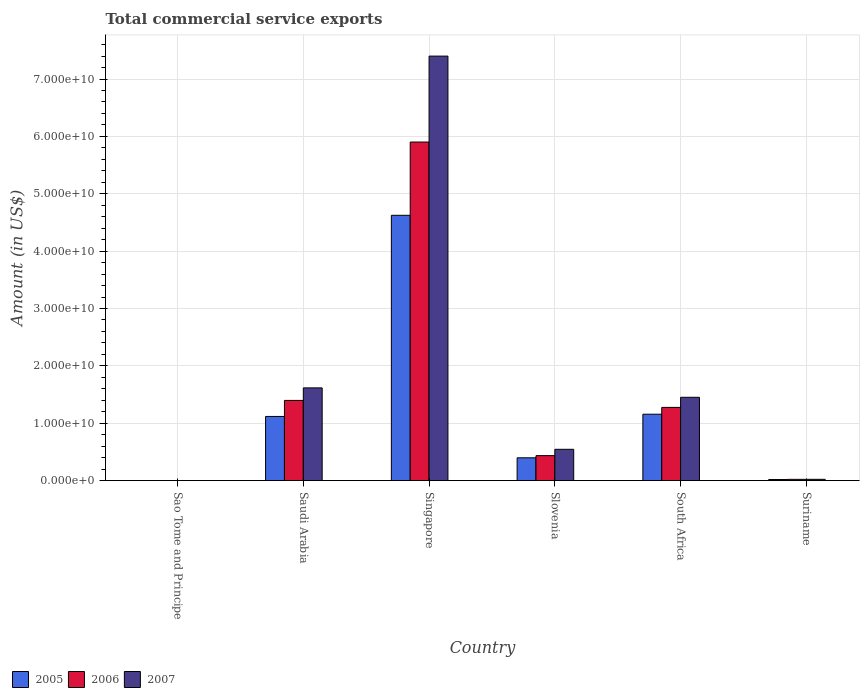How many different coloured bars are there?
Offer a terse response. 3. How many groups of bars are there?
Your answer should be very brief. 6. Are the number of bars on each tick of the X-axis equal?
Provide a succinct answer. Yes. What is the label of the 3rd group of bars from the left?
Provide a succinct answer. Singapore. In how many cases, is the number of bars for a given country not equal to the number of legend labels?
Provide a succinct answer. 0. What is the total commercial service exports in 2007 in Saudi Arabia?
Your response must be concise. 1.62e+1. Across all countries, what is the maximum total commercial service exports in 2005?
Provide a succinct answer. 4.62e+1. Across all countries, what is the minimum total commercial service exports in 2005?
Offer a terse response. 8.86e+06. In which country was the total commercial service exports in 2006 maximum?
Your answer should be very brief. Singapore. In which country was the total commercial service exports in 2007 minimum?
Keep it short and to the point. Sao Tome and Principe. What is the total total commercial service exports in 2006 in the graph?
Keep it short and to the point. 9.03e+1. What is the difference between the total commercial service exports in 2007 in Singapore and that in South Africa?
Your answer should be very brief. 5.95e+1. What is the difference between the total commercial service exports in 2007 in South Africa and the total commercial service exports in 2006 in Singapore?
Your response must be concise. -4.45e+1. What is the average total commercial service exports in 2007 per country?
Your answer should be very brief. 1.84e+1. What is the difference between the total commercial service exports of/in 2006 and total commercial service exports of/in 2007 in Suriname?
Keep it short and to the point. -5.10e+06. In how many countries, is the total commercial service exports in 2005 greater than 54000000000 US$?
Your answer should be very brief. 0. What is the ratio of the total commercial service exports in 2005 in Saudi Arabia to that in South Africa?
Ensure brevity in your answer.  0.97. What is the difference between the highest and the second highest total commercial service exports in 2006?
Your response must be concise. -4.63e+1. What is the difference between the highest and the lowest total commercial service exports in 2005?
Offer a very short reply. 4.62e+1. What is the difference between two consecutive major ticks on the Y-axis?
Ensure brevity in your answer.  1.00e+1. Where does the legend appear in the graph?
Offer a terse response. Bottom left. How are the legend labels stacked?
Your answer should be compact. Horizontal. What is the title of the graph?
Provide a short and direct response. Total commercial service exports. Does "2008" appear as one of the legend labels in the graph?
Provide a short and direct response. No. What is the label or title of the X-axis?
Your answer should be very brief. Country. What is the label or title of the Y-axis?
Provide a short and direct response. Amount (in US$). What is the Amount (in US$) in 2005 in Sao Tome and Principe?
Keep it short and to the point. 8.86e+06. What is the Amount (in US$) of 2006 in Sao Tome and Principe?
Provide a short and direct response. 8.14e+06. What is the Amount (in US$) of 2007 in Sao Tome and Principe?
Provide a short and direct response. 6.43e+06. What is the Amount (in US$) of 2005 in Saudi Arabia?
Give a very brief answer. 1.12e+1. What is the Amount (in US$) of 2006 in Saudi Arabia?
Offer a very short reply. 1.40e+1. What is the Amount (in US$) of 2007 in Saudi Arabia?
Provide a short and direct response. 1.62e+1. What is the Amount (in US$) of 2005 in Singapore?
Your answer should be very brief. 4.62e+1. What is the Amount (in US$) in 2006 in Singapore?
Give a very brief answer. 5.90e+1. What is the Amount (in US$) of 2007 in Singapore?
Make the answer very short. 7.40e+1. What is the Amount (in US$) of 2005 in Slovenia?
Provide a short and direct response. 3.97e+09. What is the Amount (in US$) in 2006 in Slovenia?
Provide a succinct answer. 4.35e+09. What is the Amount (in US$) of 2007 in Slovenia?
Ensure brevity in your answer.  5.45e+09. What is the Amount (in US$) of 2005 in South Africa?
Provide a succinct answer. 1.16e+1. What is the Amount (in US$) of 2006 in South Africa?
Offer a terse response. 1.28e+1. What is the Amount (in US$) in 2007 in South Africa?
Provide a short and direct response. 1.45e+1. What is the Amount (in US$) of 2005 in Suriname?
Your answer should be very brief. 1.83e+08. What is the Amount (in US$) in 2006 in Suriname?
Offer a very short reply. 2.14e+08. What is the Amount (in US$) of 2007 in Suriname?
Provide a short and direct response. 2.19e+08. Across all countries, what is the maximum Amount (in US$) in 2005?
Your answer should be very brief. 4.62e+1. Across all countries, what is the maximum Amount (in US$) of 2006?
Provide a succinct answer. 5.90e+1. Across all countries, what is the maximum Amount (in US$) in 2007?
Ensure brevity in your answer.  7.40e+1. Across all countries, what is the minimum Amount (in US$) in 2005?
Ensure brevity in your answer.  8.86e+06. Across all countries, what is the minimum Amount (in US$) in 2006?
Your answer should be compact. 8.14e+06. Across all countries, what is the minimum Amount (in US$) in 2007?
Offer a terse response. 6.43e+06. What is the total Amount (in US$) of 2005 in the graph?
Your response must be concise. 7.32e+1. What is the total Amount (in US$) in 2006 in the graph?
Your response must be concise. 9.03e+1. What is the total Amount (in US$) in 2007 in the graph?
Your answer should be compact. 1.10e+11. What is the difference between the Amount (in US$) of 2005 in Sao Tome and Principe and that in Saudi Arabia?
Ensure brevity in your answer.  -1.12e+1. What is the difference between the Amount (in US$) of 2006 in Sao Tome and Principe and that in Saudi Arabia?
Your answer should be compact. -1.40e+1. What is the difference between the Amount (in US$) in 2007 in Sao Tome and Principe and that in Saudi Arabia?
Make the answer very short. -1.62e+1. What is the difference between the Amount (in US$) in 2005 in Sao Tome and Principe and that in Singapore?
Offer a very short reply. -4.62e+1. What is the difference between the Amount (in US$) in 2006 in Sao Tome and Principe and that in Singapore?
Make the answer very short. -5.90e+1. What is the difference between the Amount (in US$) in 2007 in Sao Tome and Principe and that in Singapore?
Offer a very short reply. -7.40e+1. What is the difference between the Amount (in US$) of 2005 in Sao Tome and Principe and that in Slovenia?
Offer a terse response. -3.96e+09. What is the difference between the Amount (in US$) of 2006 in Sao Tome and Principe and that in Slovenia?
Provide a short and direct response. -4.34e+09. What is the difference between the Amount (in US$) in 2007 in Sao Tome and Principe and that in Slovenia?
Offer a terse response. -5.44e+09. What is the difference between the Amount (in US$) of 2005 in Sao Tome and Principe and that in South Africa?
Your response must be concise. -1.16e+1. What is the difference between the Amount (in US$) in 2006 in Sao Tome and Principe and that in South Africa?
Make the answer very short. -1.27e+1. What is the difference between the Amount (in US$) of 2007 in Sao Tome and Principe and that in South Africa?
Your response must be concise. -1.45e+1. What is the difference between the Amount (in US$) in 2005 in Sao Tome and Principe and that in Suriname?
Provide a succinct answer. -1.74e+08. What is the difference between the Amount (in US$) of 2006 in Sao Tome and Principe and that in Suriname?
Offer a very short reply. -2.05e+08. What is the difference between the Amount (in US$) of 2007 in Sao Tome and Principe and that in Suriname?
Provide a short and direct response. -2.12e+08. What is the difference between the Amount (in US$) of 2005 in Saudi Arabia and that in Singapore?
Keep it short and to the point. -3.51e+1. What is the difference between the Amount (in US$) in 2006 in Saudi Arabia and that in Singapore?
Keep it short and to the point. -4.50e+1. What is the difference between the Amount (in US$) of 2007 in Saudi Arabia and that in Singapore?
Ensure brevity in your answer.  -5.78e+1. What is the difference between the Amount (in US$) in 2005 in Saudi Arabia and that in Slovenia?
Make the answer very short. 7.21e+09. What is the difference between the Amount (in US$) of 2006 in Saudi Arabia and that in Slovenia?
Your answer should be compact. 9.62e+09. What is the difference between the Amount (in US$) in 2007 in Saudi Arabia and that in Slovenia?
Offer a very short reply. 1.07e+1. What is the difference between the Amount (in US$) in 2005 in Saudi Arabia and that in South Africa?
Give a very brief answer. -3.91e+08. What is the difference between the Amount (in US$) of 2006 in Saudi Arabia and that in South Africa?
Make the answer very short. 1.22e+09. What is the difference between the Amount (in US$) in 2007 in Saudi Arabia and that in South Africa?
Provide a succinct answer. 1.64e+09. What is the difference between the Amount (in US$) in 2005 in Saudi Arabia and that in Suriname?
Provide a short and direct response. 1.10e+1. What is the difference between the Amount (in US$) in 2006 in Saudi Arabia and that in Suriname?
Provide a succinct answer. 1.38e+1. What is the difference between the Amount (in US$) in 2007 in Saudi Arabia and that in Suriname?
Keep it short and to the point. 1.59e+1. What is the difference between the Amount (in US$) in 2005 in Singapore and that in Slovenia?
Keep it short and to the point. 4.23e+1. What is the difference between the Amount (in US$) in 2006 in Singapore and that in Slovenia?
Keep it short and to the point. 5.47e+1. What is the difference between the Amount (in US$) of 2007 in Singapore and that in Slovenia?
Make the answer very short. 6.85e+1. What is the difference between the Amount (in US$) of 2005 in Singapore and that in South Africa?
Offer a terse response. 3.47e+1. What is the difference between the Amount (in US$) of 2006 in Singapore and that in South Africa?
Offer a terse response. 4.63e+1. What is the difference between the Amount (in US$) in 2007 in Singapore and that in South Africa?
Your answer should be compact. 5.95e+1. What is the difference between the Amount (in US$) in 2005 in Singapore and that in Suriname?
Your answer should be very brief. 4.61e+1. What is the difference between the Amount (in US$) of 2006 in Singapore and that in Suriname?
Offer a terse response. 5.88e+1. What is the difference between the Amount (in US$) of 2007 in Singapore and that in Suriname?
Provide a short and direct response. 7.38e+1. What is the difference between the Amount (in US$) in 2005 in Slovenia and that in South Africa?
Ensure brevity in your answer.  -7.60e+09. What is the difference between the Amount (in US$) of 2006 in Slovenia and that in South Africa?
Offer a terse response. -8.41e+09. What is the difference between the Amount (in US$) of 2007 in Slovenia and that in South Africa?
Your answer should be very brief. -9.07e+09. What is the difference between the Amount (in US$) of 2005 in Slovenia and that in Suriname?
Your answer should be very brief. 3.79e+09. What is the difference between the Amount (in US$) in 2006 in Slovenia and that in Suriname?
Ensure brevity in your answer.  4.14e+09. What is the difference between the Amount (in US$) of 2007 in Slovenia and that in Suriname?
Your answer should be very brief. 5.23e+09. What is the difference between the Amount (in US$) of 2005 in South Africa and that in Suriname?
Provide a short and direct response. 1.14e+1. What is the difference between the Amount (in US$) in 2006 in South Africa and that in Suriname?
Provide a succinct answer. 1.25e+1. What is the difference between the Amount (in US$) in 2007 in South Africa and that in Suriname?
Provide a short and direct response. 1.43e+1. What is the difference between the Amount (in US$) of 2005 in Sao Tome and Principe and the Amount (in US$) of 2006 in Saudi Arabia?
Keep it short and to the point. -1.40e+1. What is the difference between the Amount (in US$) of 2005 in Sao Tome and Principe and the Amount (in US$) of 2007 in Saudi Arabia?
Your response must be concise. -1.62e+1. What is the difference between the Amount (in US$) in 2006 in Sao Tome and Principe and the Amount (in US$) in 2007 in Saudi Arabia?
Offer a very short reply. -1.62e+1. What is the difference between the Amount (in US$) of 2005 in Sao Tome and Principe and the Amount (in US$) of 2006 in Singapore?
Your answer should be compact. -5.90e+1. What is the difference between the Amount (in US$) of 2005 in Sao Tome and Principe and the Amount (in US$) of 2007 in Singapore?
Your answer should be very brief. -7.40e+1. What is the difference between the Amount (in US$) of 2006 in Sao Tome and Principe and the Amount (in US$) of 2007 in Singapore?
Offer a terse response. -7.40e+1. What is the difference between the Amount (in US$) of 2005 in Sao Tome and Principe and the Amount (in US$) of 2006 in Slovenia?
Give a very brief answer. -4.34e+09. What is the difference between the Amount (in US$) of 2005 in Sao Tome and Principe and the Amount (in US$) of 2007 in Slovenia?
Offer a terse response. -5.44e+09. What is the difference between the Amount (in US$) of 2006 in Sao Tome and Principe and the Amount (in US$) of 2007 in Slovenia?
Your answer should be very brief. -5.44e+09. What is the difference between the Amount (in US$) of 2005 in Sao Tome and Principe and the Amount (in US$) of 2006 in South Africa?
Provide a succinct answer. -1.27e+1. What is the difference between the Amount (in US$) of 2005 in Sao Tome and Principe and the Amount (in US$) of 2007 in South Africa?
Provide a short and direct response. -1.45e+1. What is the difference between the Amount (in US$) of 2006 in Sao Tome and Principe and the Amount (in US$) of 2007 in South Africa?
Ensure brevity in your answer.  -1.45e+1. What is the difference between the Amount (in US$) of 2005 in Sao Tome and Principe and the Amount (in US$) of 2006 in Suriname?
Make the answer very short. -2.05e+08. What is the difference between the Amount (in US$) in 2005 in Sao Tome and Principe and the Amount (in US$) in 2007 in Suriname?
Give a very brief answer. -2.10e+08. What is the difference between the Amount (in US$) in 2006 in Sao Tome and Principe and the Amount (in US$) in 2007 in Suriname?
Your answer should be compact. -2.11e+08. What is the difference between the Amount (in US$) of 2005 in Saudi Arabia and the Amount (in US$) of 2006 in Singapore?
Keep it short and to the point. -4.78e+1. What is the difference between the Amount (in US$) in 2005 in Saudi Arabia and the Amount (in US$) in 2007 in Singapore?
Your answer should be very brief. -6.28e+1. What is the difference between the Amount (in US$) in 2006 in Saudi Arabia and the Amount (in US$) in 2007 in Singapore?
Give a very brief answer. -6.00e+1. What is the difference between the Amount (in US$) in 2005 in Saudi Arabia and the Amount (in US$) in 2006 in Slovenia?
Your answer should be compact. 6.83e+09. What is the difference between the Amount (in US$) in 2005 in Saudi Arabia and the Amount (in US$) in 2007 in Slovenia?
Offer a terse response. 5.73e+09. What is the difference between the Amount (in US$) of 2006 in Saudi Arabia and the Amount (in US$) of 2007 in Slovenia?
Your answer should be compact. 8.52e+09. What is the difference between the Amount (in US$) in 2005 in Saudi Arabia and the Amount (in US$) in 2006 in South Africa?
Your answer should be very brief. -1.58e+09. What is the difference between the Amount (in US$) in 2005 in Saudi Arabia and the Amount (in US$) in 2007 in South Africa?
Make the answer very short. -3.34e+09. What is the difference between the Amount (in US$) of 2006 in Saudi Arabia and the Amount (in US$) of 2007 in South Africa?
Your answer should be compact. -5.46e+08. What is the difference between the Amount (in US$) in 2005 in Saudi Arabia and the Amount (in US$) in 2006 in Suriname?
Give a very brief answer. 1.10e+1. What is the difference between the Amount (in US$) of 2005 in Saudi Arabia and the Amount (in US$) of 2007 in Suriname?
Offer a very short reply. 1.10e+1. What is the difference between the Amount (in US$) in 2006 in Saudi Arabia and the Amount (in US$) in 2007 in Suriname?
Make the answer very short. 1.38e+1. What is the difference between the Amount (in US$) of 2005 in Singapore and the Amount (in US$) of 2006 in Slovenia?
Make the answer very short. 4.19e+1. What is the difference between the Amount (in US$) in 2005 in Singapore and the Amount (in US$) in 2007 in Slovenia?
Your answer should be compact. 4.08e+1. What is the difference between the Amount (in US$) in 2006 in Singapore and the Amount (in US$) in 2007 in Slovenia?
Your answer should be compact. 5.36e+1. What is the difference between the Amount (in US$) of 2005 in Singapore and the Amount (in US$) of 2006 in South Africa?
Your response must be concise. 3.35e+1. What is the difference between the Amount (in US$) in 2005 in Singapore and the Amount (in US$) in 2007 in South Africa?
Offer a very short reply. 3.17e+1. What is the difference between the Amount (in US$) of 2006 in Singapore and the Amount (in US$) of 2007 in South Africa?
Make the answer very short. 4.45e+1. What is the difference between the Amount (in US$) in 2005 in Singapore and the Amount (in US$) in 2006 in Suriname?
Provide a succinct answer. 4.60e+1. What is the difference between the Amount (in US$) in 2005 in Singapore and the Amount (in US$) in 2007 in Suriname?
Ensure brevity in your answer.  4.60e+1. What is the difference between the Amount (in US$) in 2006 in Singapore and the Amount (in US$) in 2007 in Suriname?
Your answer should be compact. 5.88e+1. What is the difference between the Amount (in US$) of 2005 in Slovenia and the Amount (in US$) of 2006 in South Africa?
Your answer should be compact. -8.79e+09. What is the difference between the Amount (in US$) of 2005 in Slovenia and the Amount (in US$) of 2007 in South Africa?
Your response must be concise. -1.05e+1. What is the difference between the Amount (in US$) in 2006 in Slovenia and the Amount (in US$) in 2007 in South Africa?
Your response must be concise. -1.02e+1. What is the difference between the Amount (in US$) in 2005 in Slovenia and the Amount (in US$) in 2006 in Suriname?
Your response must be concise. 3.76e+09. What is the difference between the Amount (in US$) of 2005 in Slovenia and the Amount (in US$) of 2007 in Suriname?
Your answer should be very brief. 3.75e+09. What is the difference between the Amount (in US$) in 2006 in Slovenia and the Amount (in US$) in 2007 in Suriname?
Provide a short and direct response. 4.13e+09. What is the difference between the Amount (in US$) of 2005 in South Africa and the Amount (in US$) of 2006 in Suriname?
Provide a succinct answer. 1.14e+1. What is the difference between the Amount (in US$) in 2005 in South Africa and the Amount (in US$) in 2007 in Suriname?
Your response must be concise. 1.14e+1. What is the difference between the Amount (in US$) in 2006 in South Africa and the Amount (in US$) in 2007 in Suriname?
Your response must be concise. 1.25e+1. What is the average Amount (in US$) of 2005 per country?
Your response must be concise. 1.22e+1. What is the average Amount (in US$) in 2006 per country?
Your response must be concise. 1.51e+1. What is the average Amount (in US$) of 2007 per country?
Offer a very short reply. 1.84e+1. What is the difference between the Amount (in US$) in 2005 and Amount (in US$) in 2006 in Sao Tome and Principe?
Make the answer very short. 7.25e+05. What is the difference between the Amount (in US$) of 2005 and Amount (in US$) of 2007 in Sao Tome and Principe?
Provide a short and direct response. 2.43e+06. What is the difference between the Amount (in US$) of 2006 and Amount (in US$) of 2007 in Sao Tome and Principe?
Provide a short and direct response. 1.71e+06. What is the difference between the Amount (in US$) in 2005 and Amount (in US$) in 2006 in Saudi Arabia?
Offer a terse response. -2.79e+09. What is the difference between the Amount (in US$) of 2005 and Amount (in US$) of 2007 in Saudi Arabia?
Keep it short and to the point. -4.98e+09. What is the difference between the Amount (in US$) in 2006 and Amount (in US$) in 2007 in Saudi Arabia?
Keep it short and to the point. -2.19e+09. What is the difference between the Amount (in US$) in 2005 and Amount (in US$) in 2006 in Singapore?
Ensure brevity in your answer.  -1.28e+1. What is the difference between the Amount (in US$) of 2005 and Amount (in US$) of 2007 in Singapore?
Provide a short and direct response. -2.78e+1. What is the difference between the Amount (in US$) in 2006 and Amount (in US$) in 2007 in Singapore?
Provide a succinct answer. -1.50e+1. What is the difference between the Amount (in US$) of 2005 and Amount (in US$) of 2006 in Slovenia?
Provide a succinct answer. -3.80e+08. What is the difference between the Amount (in US$) of 2005 and Amount (in US$) of 2007 in Slovenia?
Ensure brevity in your answer.  -1.48e+09. What is the difference between the Amount (in US$) in 2006 and Amount (in US$) in 2007 in Slovenia?
Offer a terse response. -1.10e+09. What is the difference between the Amount (in US$) in 2005 and Amount (in US$) in 2006 in South Africa?
Offer a very short reply. -1.19e+09. What is the difference between the Amount (in US$) of 2005 and Amount (in US$) of 2007 in South Africa?
Ensure brevity in your answer.  -2.95e+09. What is the difference between the Amount (in US$) in 2006 and Amount (in US$) in 2007 in South Africa?
Provide a succinct answer. -1.76e+09. What is the difference between the Amount (in US$) in 2005 and Amount (in US$) in 2006 in Suriname?
Offer a terse response. -3.10e+07. What is the difference between the Amount (in US$) in 2005 and Amount (in US$) in 2007 in Suriname?
Make the answer very short. -3.61e+07. What is the difference between the Amount (in US$) of 2006 and Amount (in US$) of 2007 in Suriname?
Your answer should be compact. -5.10e+06. What is the ratio of the Amount (in US$) of 2005 in Sao Tome and Principe to that in Saudi Arabia?
Make the answer very short. 0. What is the ratio of the Amount (in US$) in 2006 in Sao Tome and Principe to that in Saudi Arabia?
Your answer should be very brief. 0. What is the ratio of the Amount (in US$) in 2005 in Sao Tome and Principe to that in Singapore?
Your answer should be compact. 0. What is the ratio of the Amount (in US$) in 2006 in Sao Tome and Principe to that in Singapore?
Your response must be concise. 0. What is the ratio of the Amount (in US$) of 2007 in Sao Tome and Principe to that in Singapore?
Ensure brevity in your answer.  0. What is the ratio of the Amount (in US$) in 2005 in Sao Tome and Principe to that in Slovenia?
Keep it short and to the point. 0. What is the ratio of the Amount (in US$) of 2006 in Sao Tome and Principe to that in Slovenia?
Ensure brevity in your answer.  0. What is the ratio of the Amount (in US$) of 2007 in Sao Tome and Principe to that in Slovenia?
Give a very brief answer. 0. What is the ratio of the Amount (in US$) in 2005 in Sao Tome and Principe to that in South Africa?
Provide a succinct answer. 0. What is the ratio of the Amount (in US$) in 2006 in Sao Tome and Principe to that in South Africa?
Give a very brief answer. 0. What is the ratio of the Amount (in US$) in 2005 in Sao Tome and Principe to that in Suriname?
Your answer should be compact. 0.05. What is the ratio of the Amount (in US$) in 2006 in Sao Tome and Principe to that in Suriname?
Your answer should be very brief. 0.04. What is the ratio of the Amount (in US$) of 2007 in Sao Tome and Principe to that in Suriname?
Ensure brevity in your answer.  0.03. What is the ratio of the Amount (in US$) of 2005 in Saudi Arabia to that in Singapore?
Provide a short and direct response. 0.24. What is the ratio of the Amount (in US$) of 2006 in Saudi Arabia to that in Singapore?
Make the answer very short. 0.24. What is the ratio of the Amount (in US$) in 2007 in Saudi Arabia to that in Singapore?
Provide a short and direct response. 0.22. What is the ratio of the Amount (in US$) of 2005 in Saudi Arabia to that in Slovenia?
Your answer should be very brief. 2.82. What is the ratio of the Amount (in US$) of 2006 in Saudi Arabia to that in Slovenia?
Your answer should be very brief. 3.21. What is the ratio of the Amount (in US$) in 2007 in Saudi Arabia to that in Slovenia?
Give a very brief answer. 2.96. What is the ratio of the Amount (in US$) in 2005 in Saudi Arabia to that in South Africa?
Your answer should be very brief. 0.97. What is the ratio of the Amount (in US$) of 2006 in Saudi Arabia to that in South Africa?
Offer a terse response. 1.1. What is the ratio of the Amount (in US$) in 2007 in Saudi Arabia to that in South Africa?
Give a very brief answer. 1.11. What is the ratio of the Amount (in US$) in 2005 in Saudi Arabia to that in Suriname?
Offer a very short reply. 61.22. What is the ratio of the Amount (in US$) of 2006 in Saudi Arabia to that in Suriname?
Your answer should be very brief. 65.42. What is the ratio of the Amount (in US$) in 2007 in Saudi Arabia to that in Suriname?
Your answer should be very brief. 73.89. What is the ratio of the Amount (in US$) in 2005 in Singapore to that in Slovenia?
Ensure brevity in your answer.  11.65. What is the ratio of the Amount (in US$) of 2006 in Singapore to that in Slovenia?
Ensure brevity in your answer.  13.57. What is the ratio of the Amount (in US$) of 2007 in Singapore to that in Slovenia?
Ensure brevity in your answer.  13.58. What is the ratio of the Amount (in US$) of 2005 in Singapore to that in South Africa?
Your answer should be very brief. 4. What is the ratio of the Amount (in US$) in 2006 in Singapore to that in South Africa?
Give a very brief answer. 4.63. What is the ratio of the Amount (in US$) of 2007 in Singapore to that in South Africa?
Offer a very short reply. 5.1. What is the ratio of the Amount (in US$) of 2005 in Singapore to that in Suriname?
Provide a short and direct response. 253.25. What is the ratio of the Amount (in US$) of 2006 in Singapore to that in Suriname?
Provide a succinct answer. 276.28. What is the ratio of the Amount (in US$) of 2007 in Singapore to that in Suriname?
Make the answer very short. 338.34. What is the ratio of the Amount (in US$) of 2005 in Slovenia to that in South Africa?
Your answer should be very brief. 0.34. What is the ratio of the Amount (in US$) of 2006 in Slovenia to that in South Africa?
Your answer should be very brief. 0.34. What is the ratio of the Amount (in US$) in 2007 in Slovenia to that in South Africa?
Your answer should be compact. 0.38. What is the ratio of the Amount (in US$) in 2005 in Slovenia to that in Suriname?
Your answer should be compact. 21.74. What is the ratio of the Amount (in US$) of 2006 in Slovenia to that in Suriname?
Provide a short and direct response. 20.36. What is the ratio of the Amount (in US$) in 2007 in Slovenia to that in Suriname?
Keep it short and to the point. 24.92. What is the ratio of the Amount (in US$) of 2005 in South Africa to that in Suriname?
Offer a very short reply. 63.36. What is the ratio of the Amount (in US$) in 2006 in South Africa to that in Suriname?
Your answer should be compact. 59.72. What is the ratio of the Amount (in US$) of 2007 in South Africa to that in Suriname?
Keep it short and to the point. 66.39. What is the difference between the highest and the second highest Amount (in US$) of 2005?
Offer a terse response. 3.47e+1. What is the difference between the highest and the second highest Amount (in US$) in 2006?
Offer a very short reply. 4.50e+1. What is the difference between the highest and the second highest Amount (in US$) of 2007?
Your response must be concise. 5.78e+1. What is the difference between the highest and the lowest Amount (in US$) in 2005?
Your answer should be compact. 4.62e+1. What is the difference between the highest and the lowest Amount (in US$) of 2006?
Provide a succinct answer. 5.90e+1. What is the difference between the highest and the lowest Amount (in US$) in 2007?
Offer a terse response. 7.40e+1. 